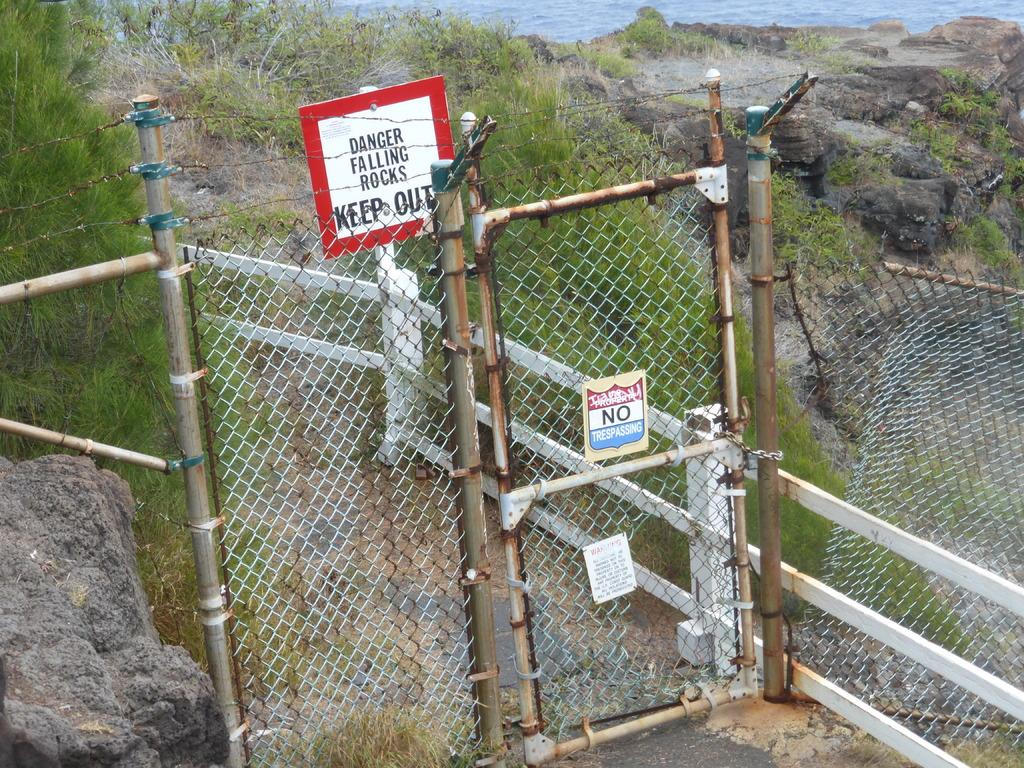What type of barrier is present in the image? There is a fence with an entrance in the image. Can you describe the fence's construction? The fence has boards and metal wires. What is located at the bottom left of the image? There is a stone at the bottom left of the image. What can be seen in the distance in the image? There are hills, plants, and water visible in the background of the image. Is there a fight taking place between the plants and the water in the background of the image? No, there is no fight between the plants and the water in the image. The plants and water are simply elements of the background landscape. 